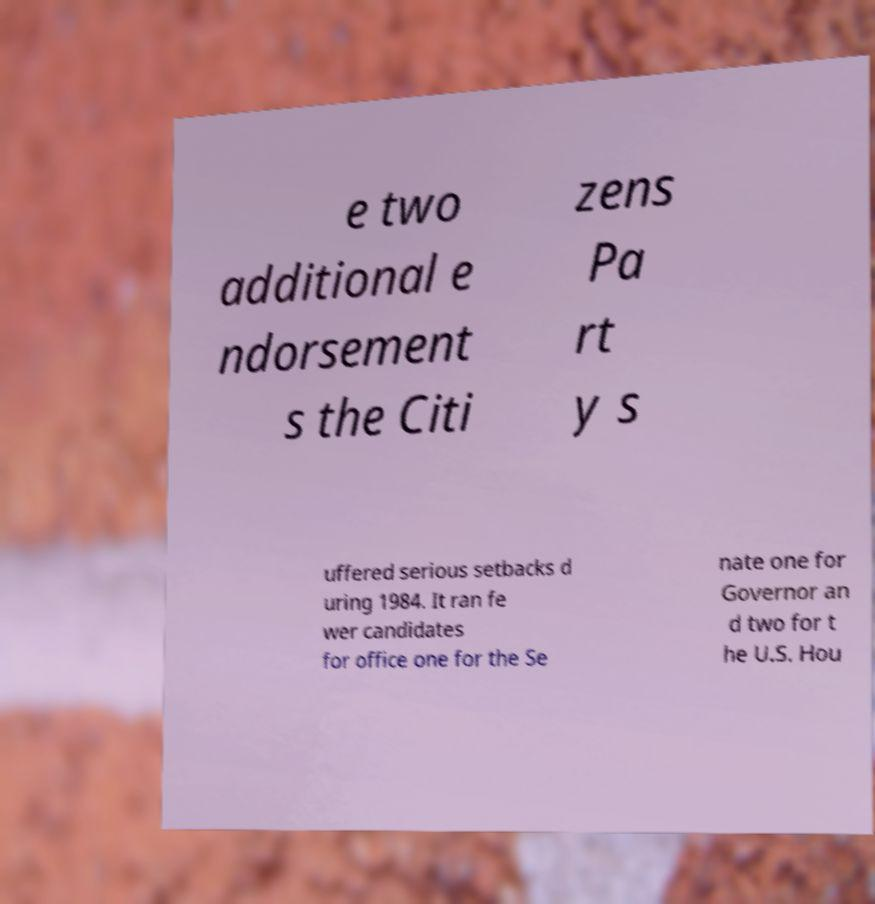Could you extract and type out the text from this image? e two additional e ndorsement s the Citi zens Pa rt y s uffered serious setbacks d uring 1984. It ran fe wer candidates for office one for the Se nate one for Governor an d two for t he U.S. Hou 